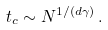Convert formula to latex. <formula><loc_0><loc_0><loc_500><loc_500>t _ { c } \sim N ^ { 1 / ( d \gamma ) } \, .</formula> 